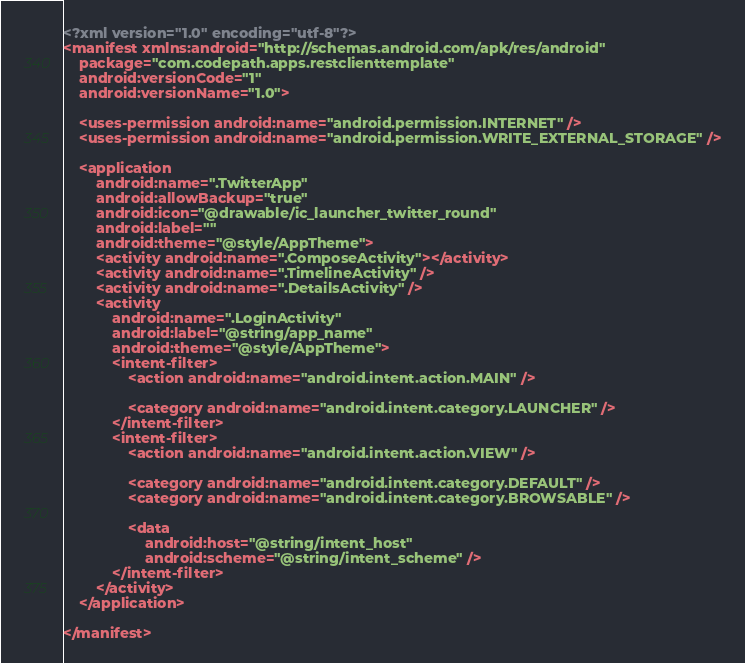Convert code to text. <code><loc_0><loc_0><loc_500><loc_500><_XML_><?xml version="1.0" encoding="utf-8"?>
<manifest xmlns:android="http://schemas.android.com/apk/res/android"
    package="com.codepath.apps.restclienttemplate"
    android:versionCode="1"
    android:versionName="1.0">

    <uses-permission android:name="android.permission.INTERNET" />
    <uses-permission android:name="android.permission.WRITE_EXTERNAL_STORAGE" />

    <application
        android:name=".TwitterApp"
        android:allowBackup="true"
        android:icon="@drawable/ic_launcher_twitter_round"
        android:label=""
        android:theme="@style/AppTheme">
        <activity android:name=".ComposeActivity"></activity>
        <activity android:name=".TimelineActivity" />
        <activity android:name=".DetailsActivity" />
        <activity
            android:name=".LoginActivity"
            android:label="@string/app_name"
            android:theme="@style/AppTheme">
            <intent-filter>
                <action android:name="android.intent.action.MAIN" />

                <category android:name="android.intent.category.LAUNCHER" />
            </intent-filter>
            <intent-filter>
                <action android:name="android.intent.action.VIEW" />

                <category android:name="android.intent.category.DEFAULT" />
                <category android:name="android.intent.category.BROWSABLE" />

                <data
                    android:host="@string/intent_host"
                    android:scheme="@string/intent_scheme" />
            </intent-filter>
        </activity>
    </application>

</manifest></code> 